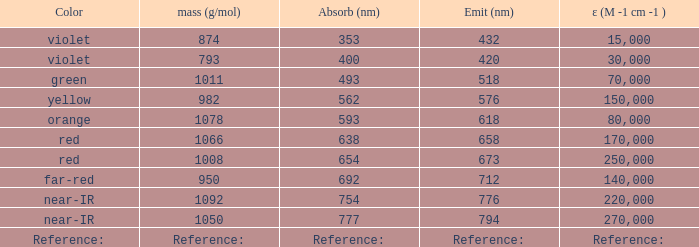Which wavelength (in nanometers) has an absorption equal to 593 nm? 618.0. I'm looking to parse the entire table for insights. Could you assist me with that? {'header': ['Color', 'mass (g/mol)', 'Absorb (nm)', 'Emit (nm)', 'ε (M -1 cm -1 )'], 'rows': [['violet', '874', '353', '432', '15,000'], ['violet', '793', '400', '420', '30,000'], ['green', '1011', '493', '518', '70,000'], ['yellow', '982', '562', '576', '150,000'], ['orange', '1078', '593', '618', '80,000'], ['red', '1066', '638', '658', '170,000'], ['red', '1008', '654', '673', '250,000'], ['far-red', '950', '692', '712', '140,000'], ['near-IR', '1092', '754', '776', '220,000'], ['near-IR', '1050', '777', '794', '270,000'], ['Reference:', 'Reference:', 'Reference:', 'Reference:', 'Reference:']]} 